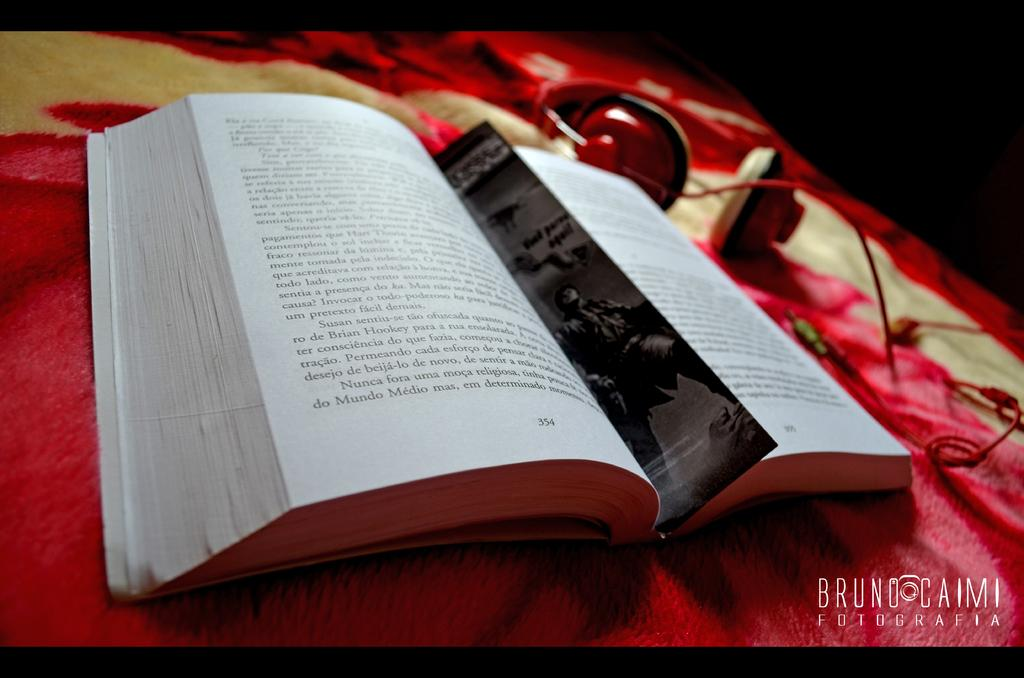<image>
Provide a brief description of the given image. Book opened with a bookmark and next to red headphones by Bruno Fotografia 